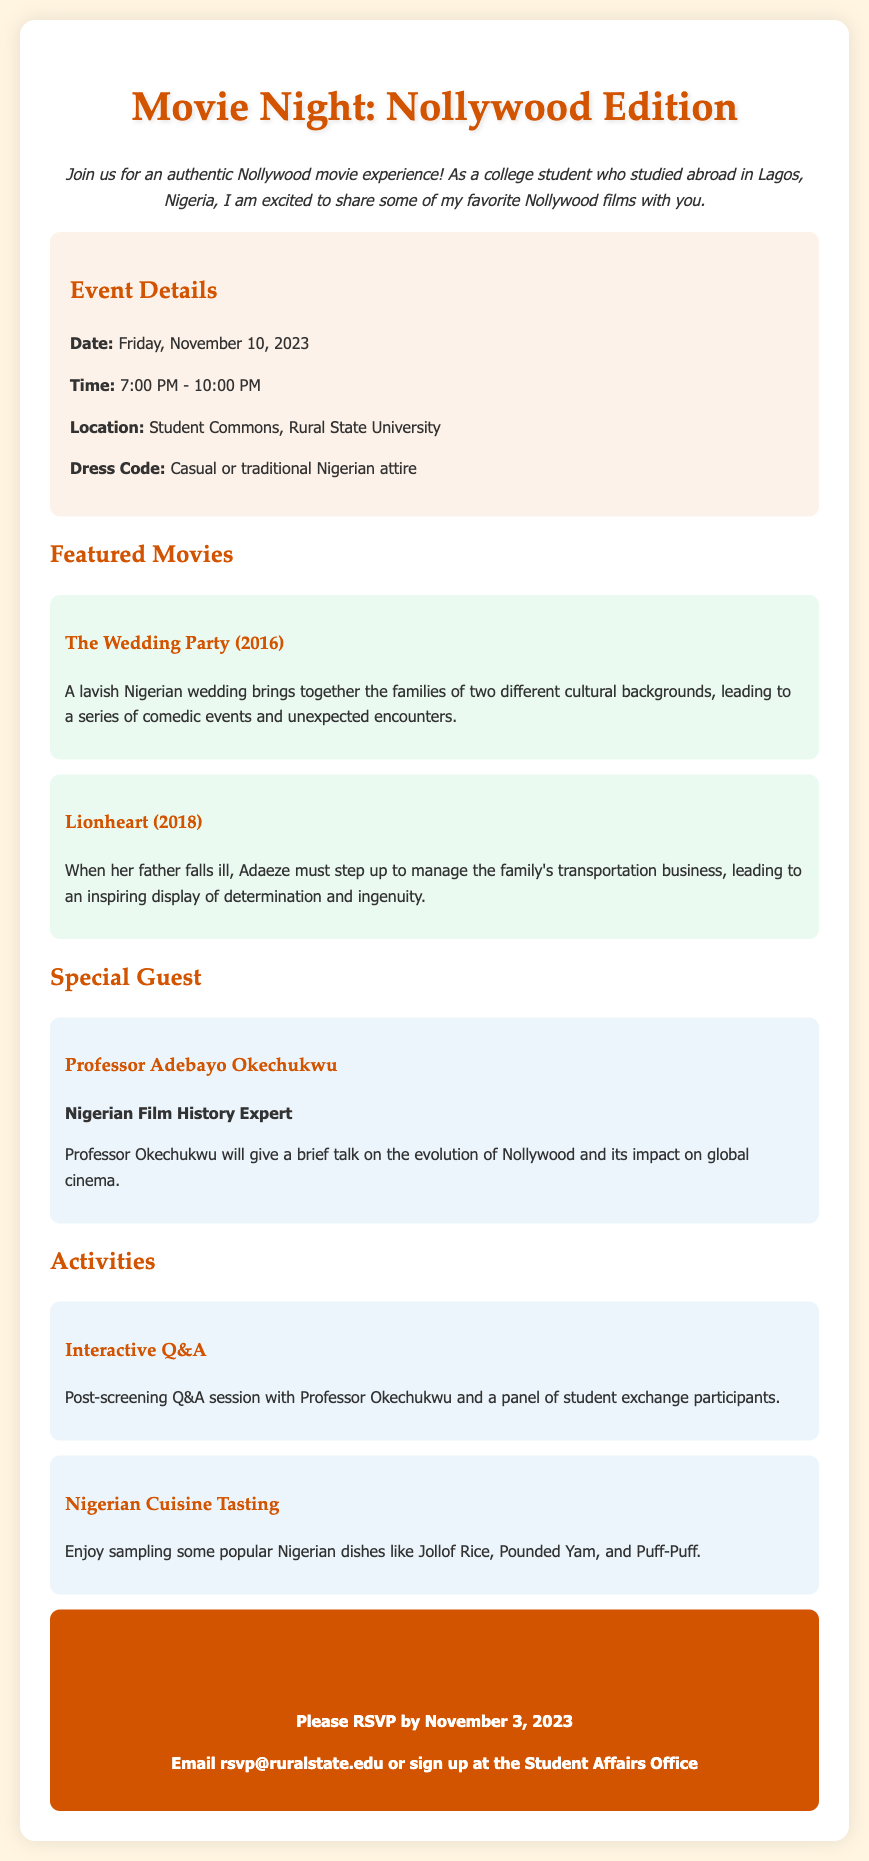what is the date of the event? The document specifies that the event is on Friday, November 10, 2023.
Answer: November 10, 2023 what time does the event start? The document mentions that the event starts at 7:00 PM.
Answer: 7:00 PM where is the event located? The RSVP card states that the location is the Student Commons, Rural State University.
Answer: Student Commons, Rural State University who is the special guest at the event? The document lists Professor Adebayo Okechukwu as the special guest.
Answer: Professor Adebayo Okechukwu what is one of the activities listed in the document? The document describes "Nigerian Cuisine Tasting" as one of the activities.
Answer: Nigerian Cuisine Tasting how long will the event last? The event is scheduled to last from 7:00 PM to 10:00 PM, which is three hours.
Answer: three hours what is the dress code for the event? The RSVP states the dress code is casual or traditional Nigerian attire.
Answer: Casual or traditional Nigerian attire when is the RSVP deadline? The document specifies that RSVPs should be submitted by November 3, 2023.
Answer: November 3, 2023 what type of film will be featured at the event? The RSVP card highlights Nollywood films as the type of films being featured.
Answer: Nollywood films 